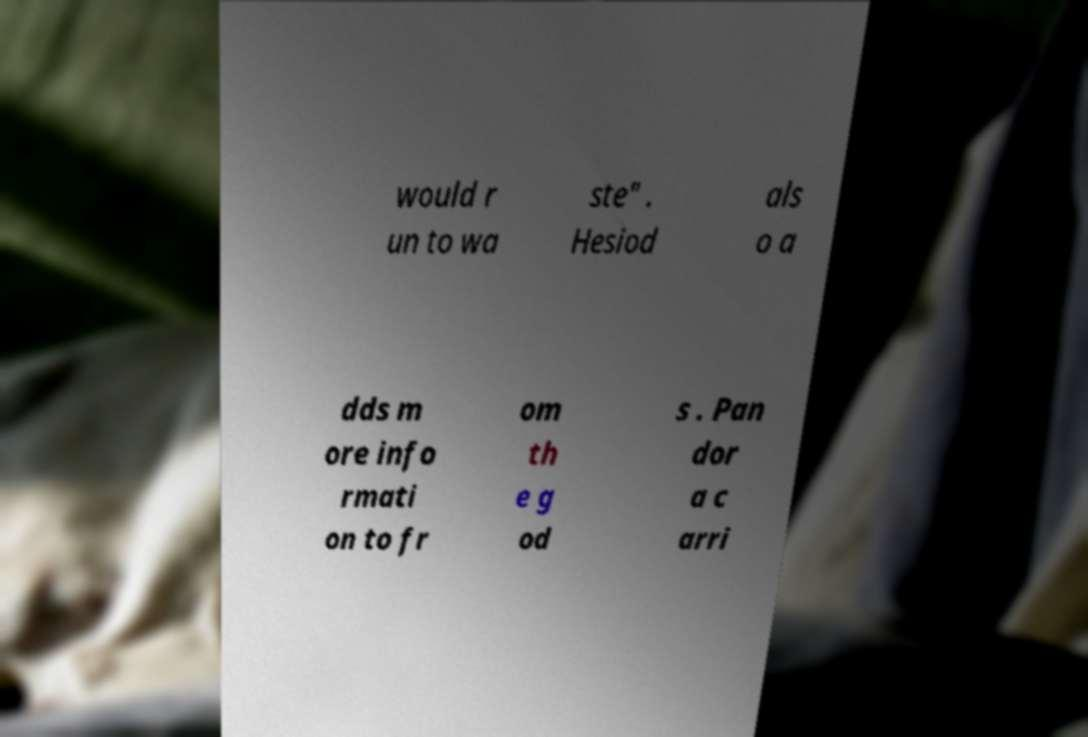Could you assist in decoding the text presented in this image and type it out clearly? would r un to wa ste" . Hesiod als o a dds m ore info rmati on to fr om th e g od s . Pan dor a c arri 